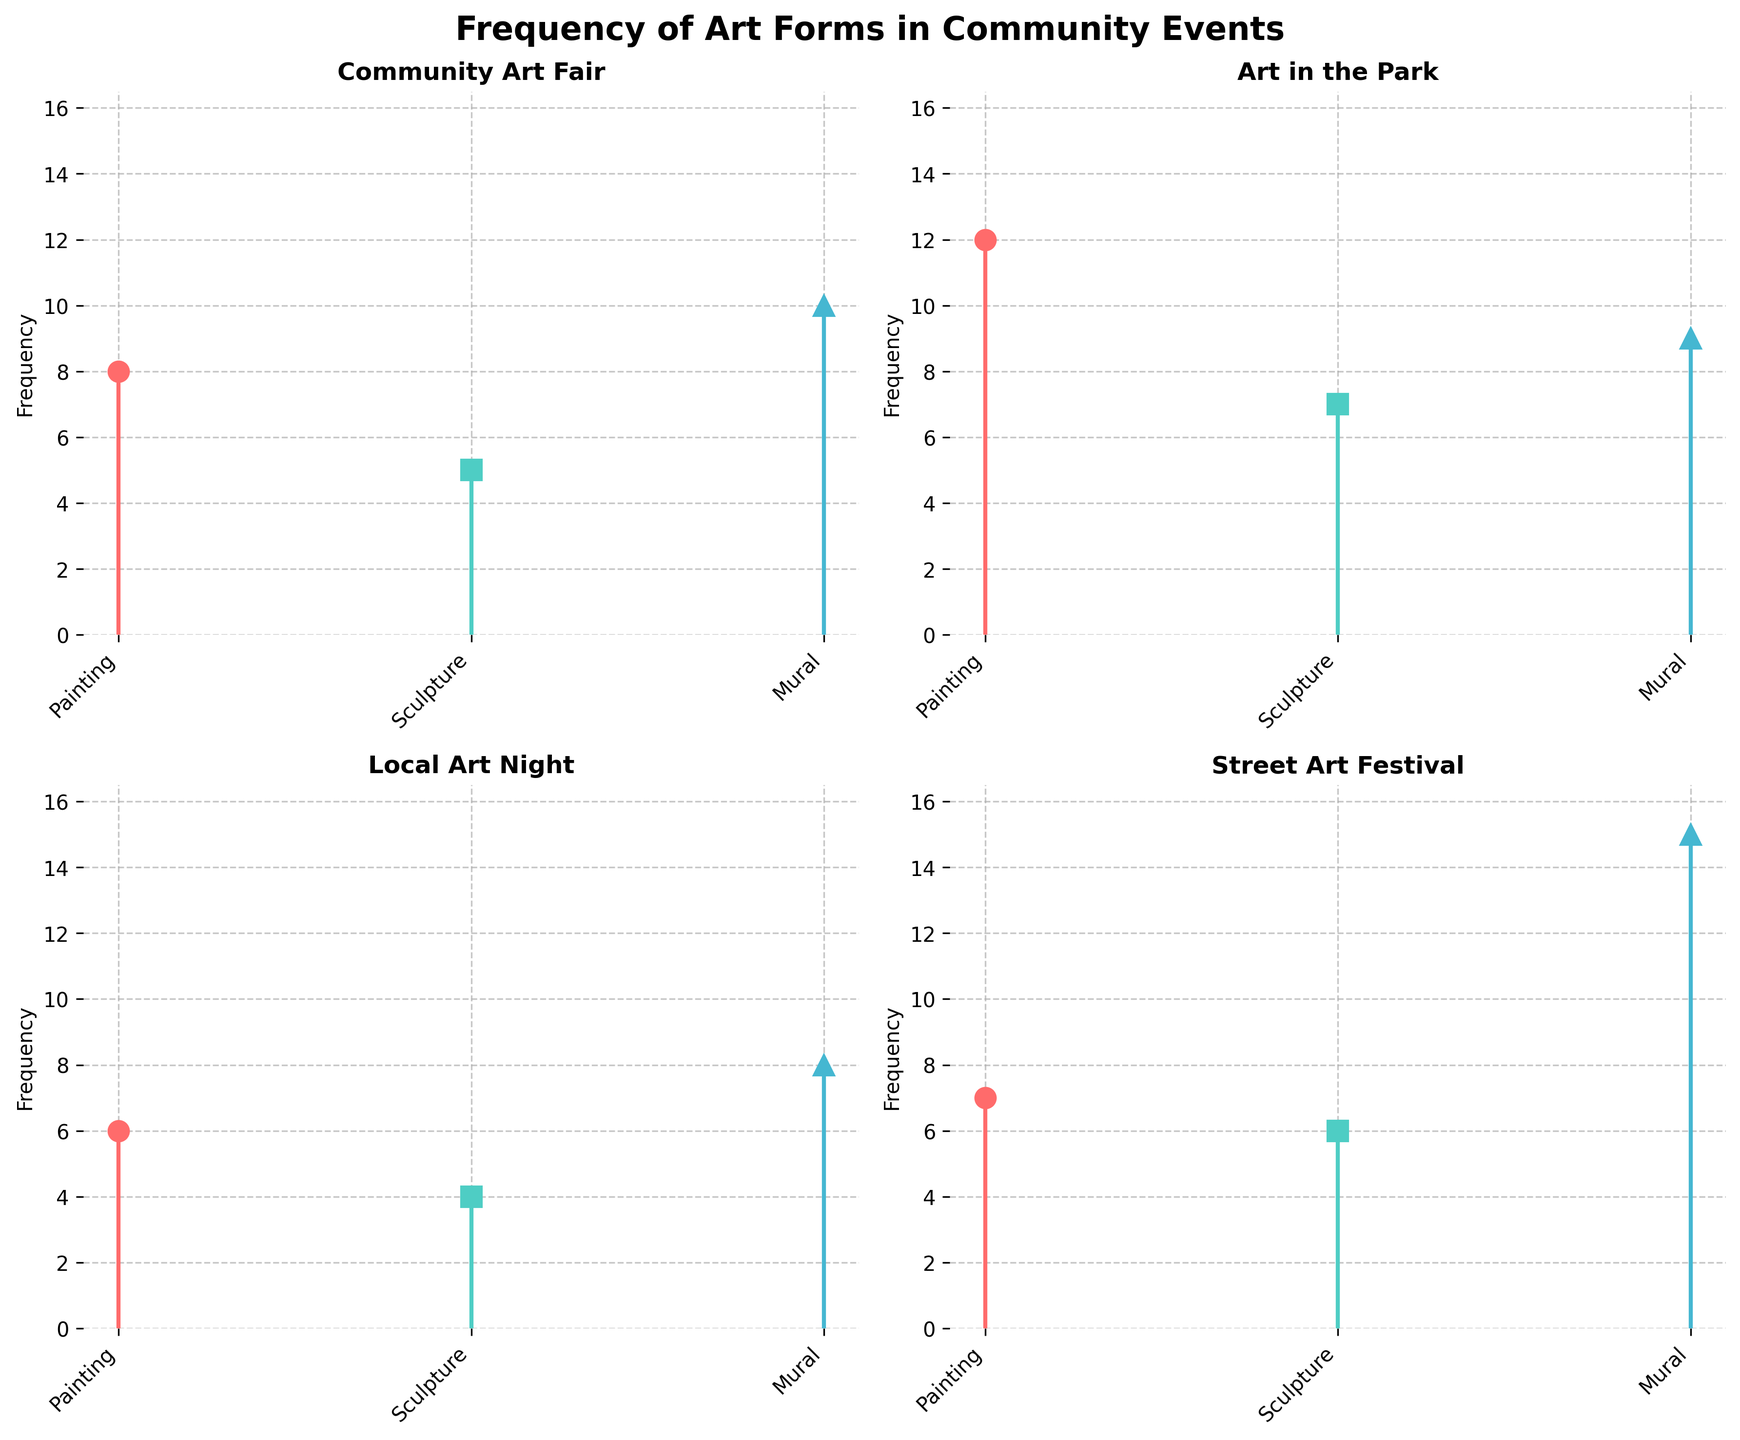What is the title of the figure? The title of the figure is mentioned at the top of the plot. It reads 'Frequency of Art Forms in Community Events'.
Answer: Frequency of Art Forms in Community Events How many different community events are displayed in the figure? There are four subplots, each representing a different community event. The events are 'Community Art Fair', 'Art in the Park', 'Local Art Night', and 'Street Art Festival'.
Answer: 4 Which art form has the highest frequency in the 'Street Art Festival'? By looking at the subplot for the 'Street Art Festival', the highest stem reaches up to 15 for the 'Mural' art form.
Answer: Mural What is the average frequency of 'Sculpture' across all events? The frequencies of 'Sculpture' in the events are 5, 7, 4, and 6. Sum these up to get 22, then divide by the number of events: 22/4.
Answer: 5.5 Which event has the lowest frequency for 'Painting'? By comparing the subplots for each event, 'Local Art Night' has the lowest stem for 'Painting', with a frequency of 6.
Answer: Local Art Night What is the total frequency of 'Mural' across all events? The frequencies of 'Mural' in each event are 10, 9, 8, and 15. Adding these numbers results in a total of 42.
Answer: 42 Compare the frequency of 'Painting' and 'Sculpture' in 'Art in the Park'. Which one is higher? In 'Art in the Park', the stem for 'Painting' is at 12, while 'Sculpture' is at 7. So, 'Painting' has a higher frequency.
Answer: Painting Which event has the most balanced frequencies across all art forms? 'Community Art Fair' has 8 for 'Painting', 5 for 'Sculpture', and 10 for 'Mural'. The frequencies are close to each other, indicating it is more balanced compared to other events.
Answer: Community Art Fair 